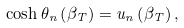Convert formula to latex. <formula><loc_0><loc_0><loc_500><loc_500>\cosh \theta _ { n } \left ( \beta _ { T } \right ) = u _ { n } \left ( \beta _ { T } \right ) ,</formula> 